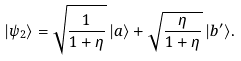<formula> <loc_0><loc_0><loc_500><loc_500>| \psi _ { 2 } \rangle = \sqrt { \frac { 1 } { 1 + \eta } } \, | a \rangle + \sqrt { \frac { \eta } { 1 + \eta } } \, | b ^ { \prime } \rangle .</formula> 